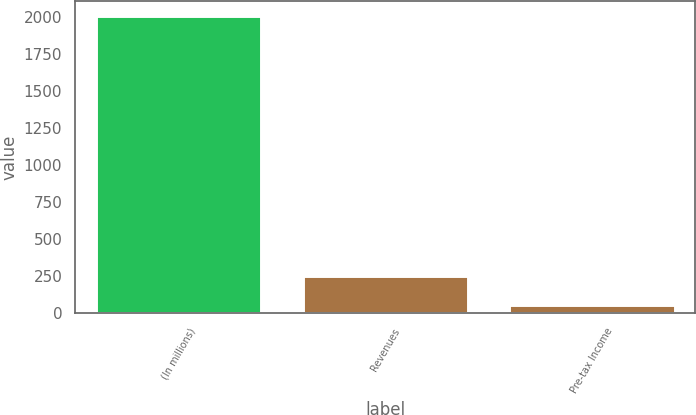<chart> <loc_0><loc_0><loc_500><loc_500><bar_chart><fcel>(In millions)<fcel>Revenues<fcel>Pre-tax Income<nl><fcel>2010<fcel>254.01<fcel>58.9<nl></chart> 